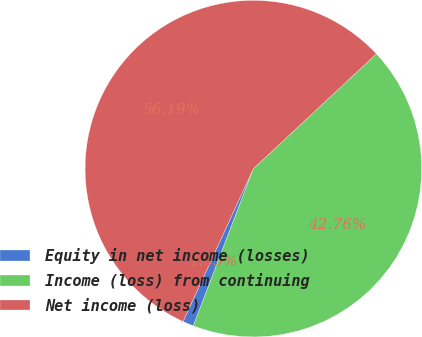<chart> <loc_0><loc_0><loc_500><loc_500><pie_chart><fcel>Equity in net income (losses)<fcel>Income (loss) from continuing<fcel>Net income (loss)<nl><fcel>1.05%<fcel>42.76%<fcel>56.19%<nl></chart> 